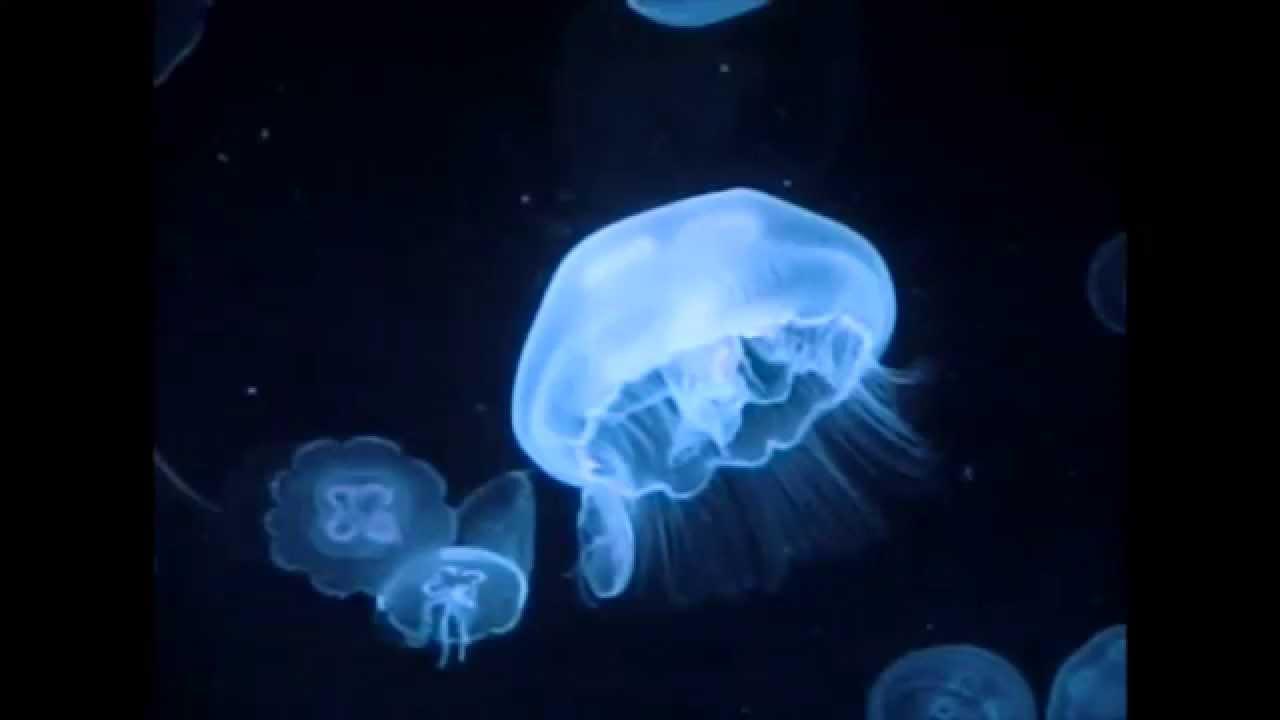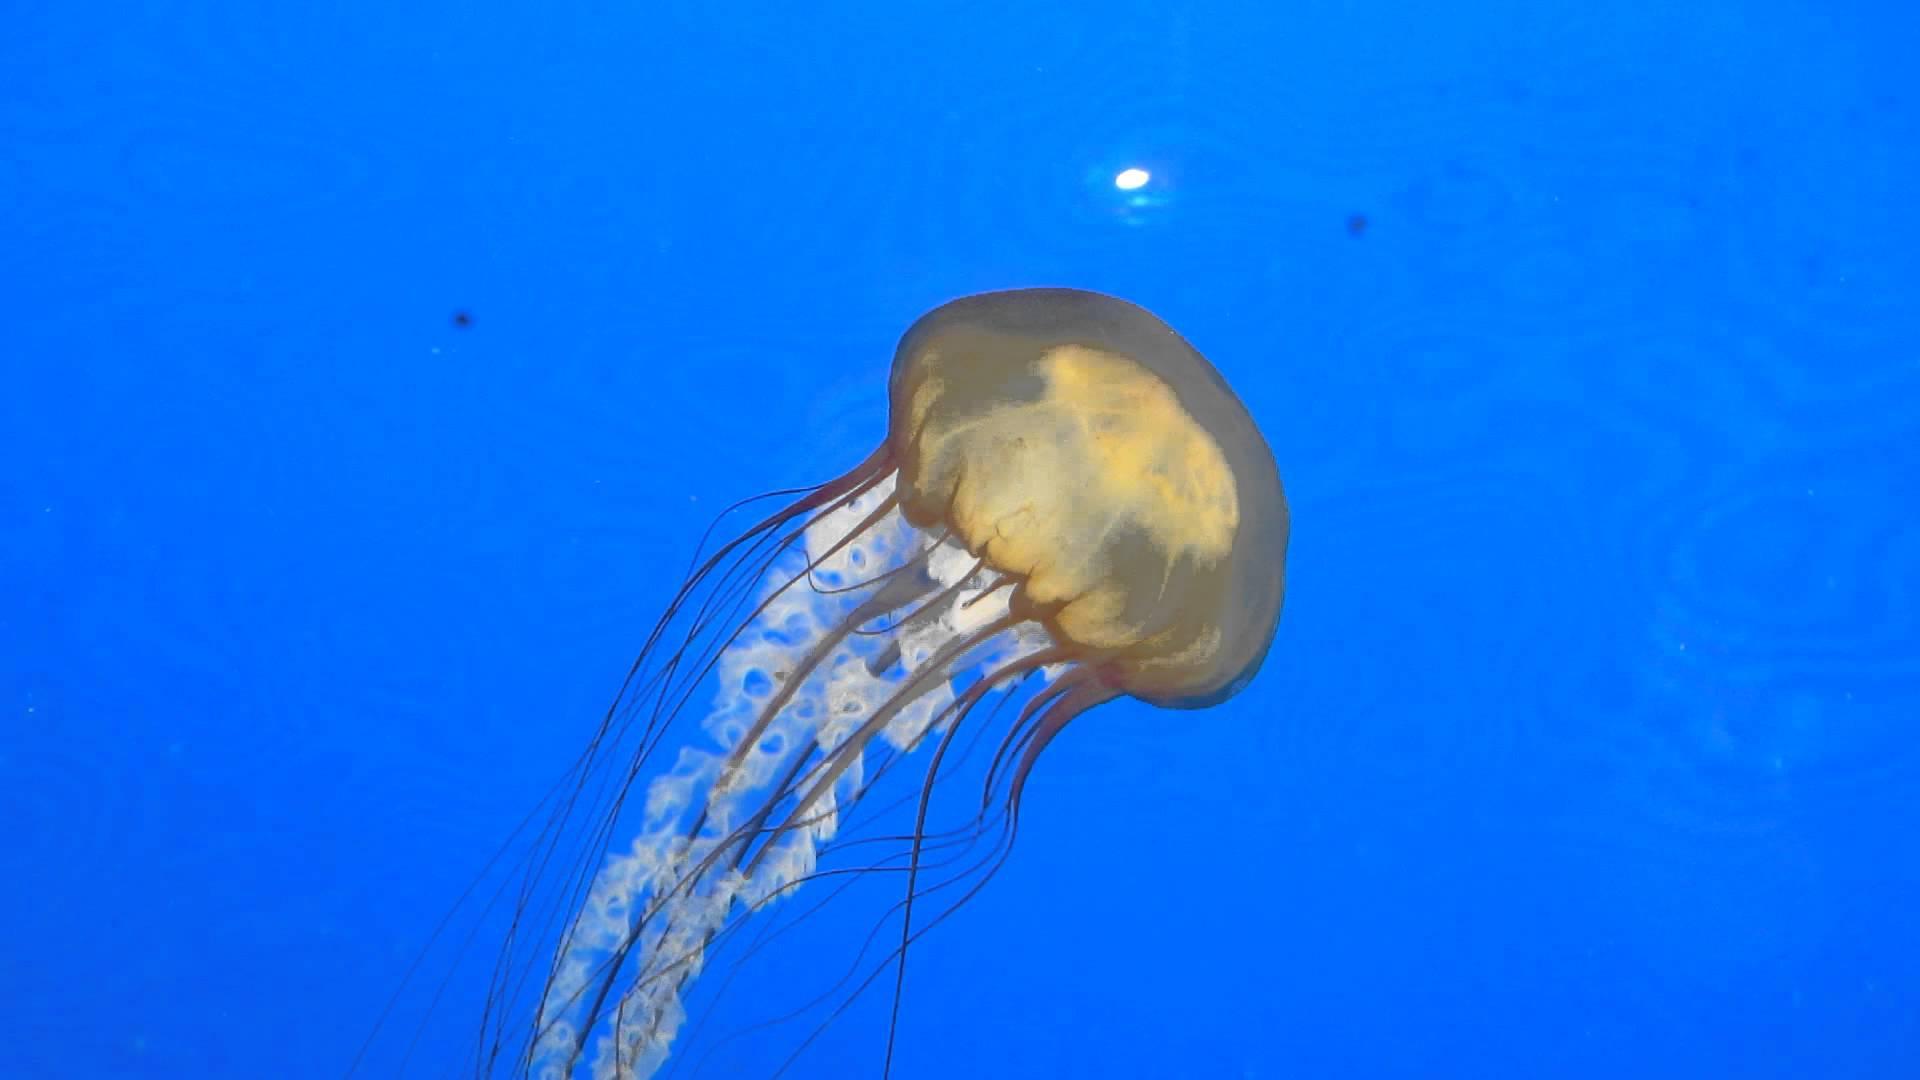The first image is the image on the left, the second image is the image on the right. Assess this claim about the two images: "Several jellyfish are swimming in the water in the image on the left.". Correct or not? Answer yes or no. Yes. 